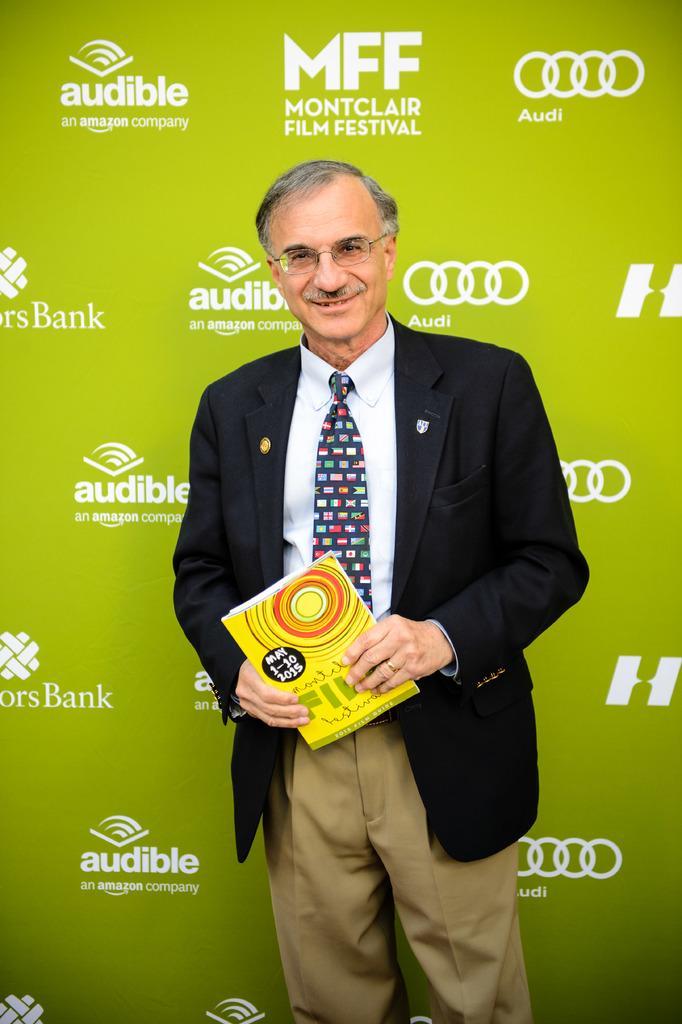In one or two sentences, can you explain what this image depicts? In this image, we can see a man standing and holding an object, he is wearing a black coat and a tie, in the background, we can see a poster and there are some logos on the poster. 